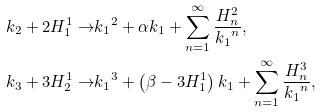<formula> <loc_0><loc_0><loc_500><loc_500>k _ { 2 } + 2 H ^ { 1 } _ { 1 } \to & { k _ { 1 } } ^ { 2 } + \alpha k _ { 1 } + \sum _ { n = 1 } ^ { \infty } \frac { H ^ { 2 } _ { n } } { { k _ { 1 } } ^ { n } } , \\ k _ { 3 } + 3 H ^ { 1 } _ { 2 } \to & { k _ { 1 } } ^ { 3 } + \left ( \beta - 3 H ^ { 1 } _ { 1 } \right ) k _ { 1 } + \sum _ { n = 1 } ^ { \infty } \frac { H ^ { 3 } _ { n } } { { k _ { 1 } } ^ { n } } ,</formula> 